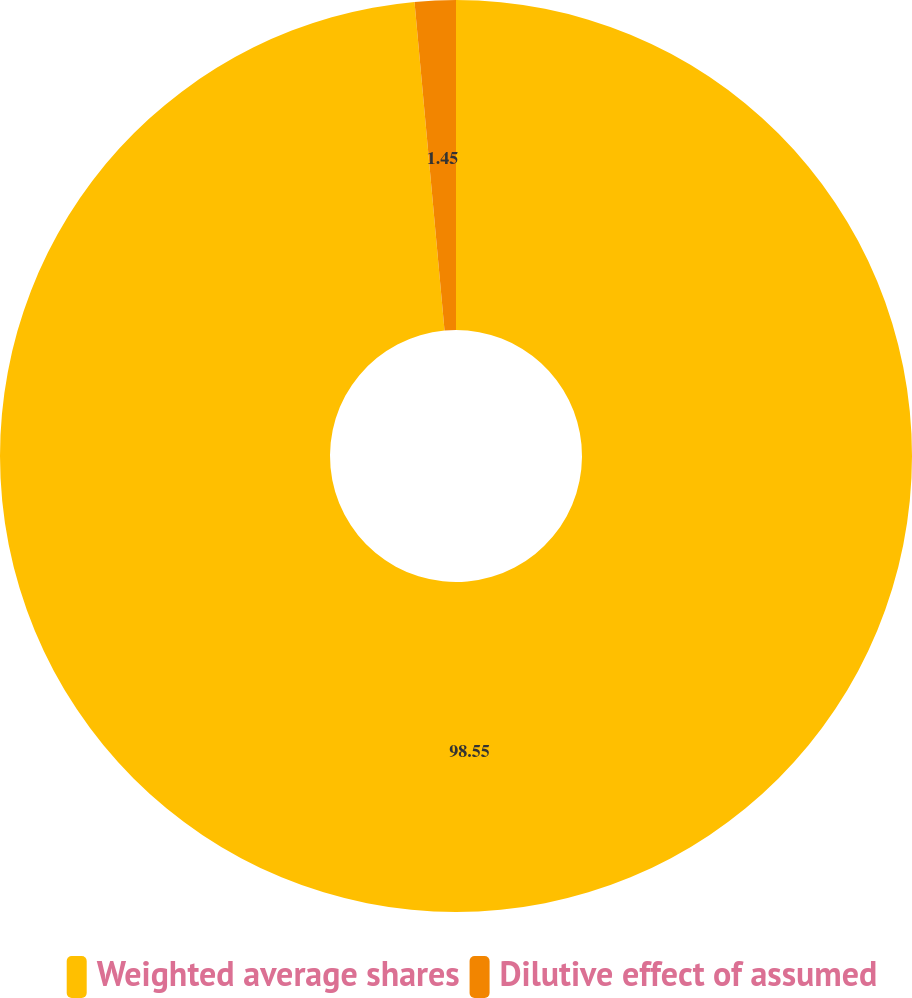Convert chart. <chart><loc_0><loc_0><loc_500><loc_500><pie_chart><fcel>Weighted average shares<fcel>Dilutive effect of assumed<nl><fcel>98.55%<fcel>1.45%<nl></chart> 